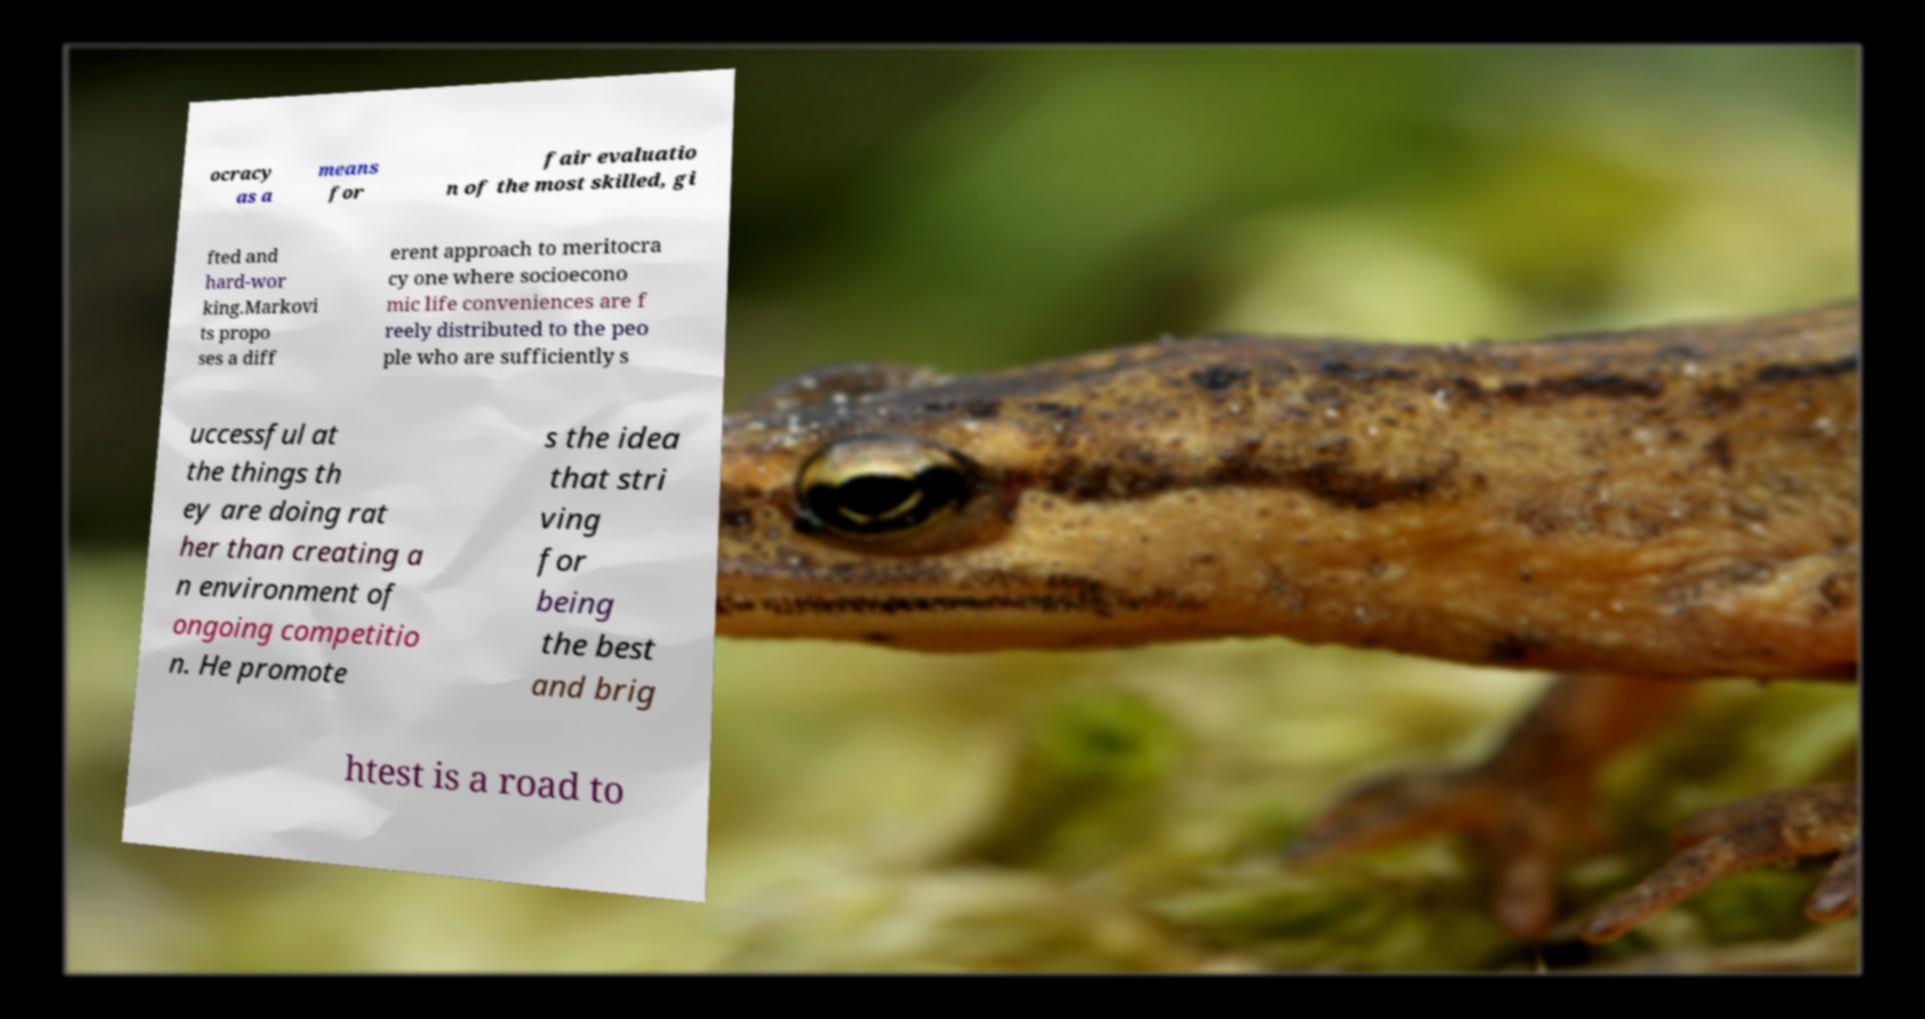Can you read and provide the text displayed in the image?This photo seems to have some interesting text. Can you extract and type it out for me? ocracy as a means for fair evaluatio n of the most skilled, gi fted and hard-wor king.Markovi ts propo ses a diff erent approach to meritocra cy one where socioecono mic life conveniences are f reely distributed to the peo ple who are sufficiently s uccessful at the things th ey are doing rat her than creating a n environment of ongoing competitio n. He promote s the idea that stri ving for being the best and brig htest is a road to 